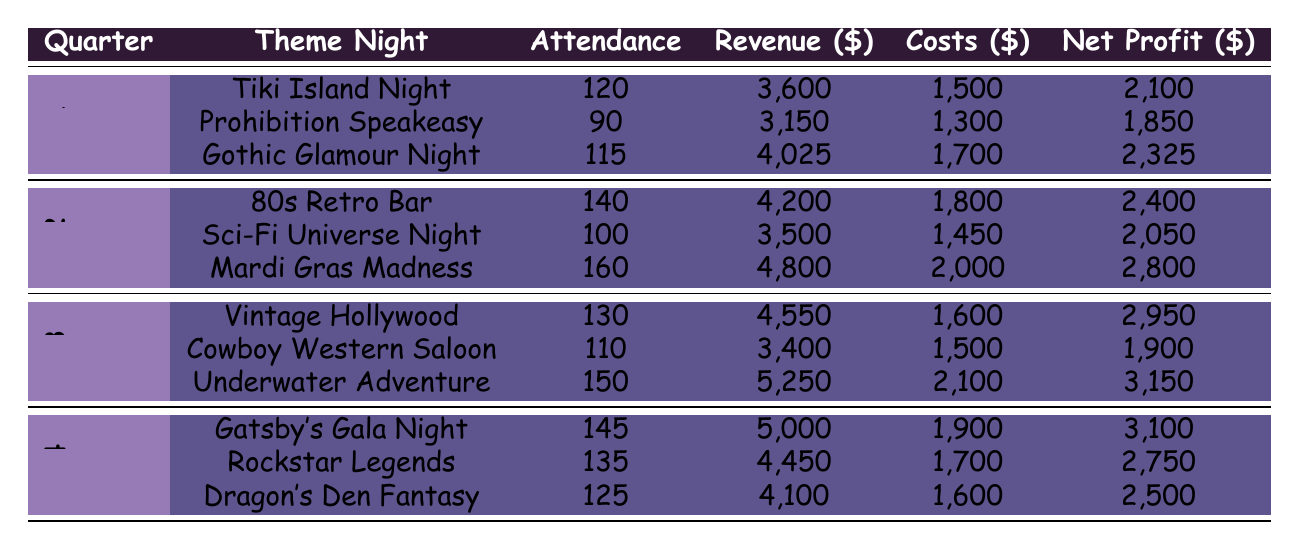What was the theme night with the highest net profit in Q1? In Q1, the net profits for the theme nights are as follows: Tiki Island Night: 2100, Prohibition Speakeasy: 1850, Gothic Glamour Night: 2325. The highest net profit is from Gothic Glamour Night.
Answer: Gothic Glamour Night What was the total attendance across all theme nights in Q2? The attendances for Q2 theme nights are: 80s Retro Bar: 140, Sci-Fi Universe Night: 100, Mardi Gras Madness: 160. Summing these values gives us 140 + 100 + 160 = 400.
Answer: 400 Did the Underwater Adventure theme night in Q3 have higher costs than the Gothic Glamour Night in Q1? The costs for Underwater Adventure in Q3 are 2100 and for Gothic Glamour Night in Q1 are 1700. Since 2100 is greater than 1700, the statement is true.
Answer: Yes Which quarter had the highest overall net profit from all theme nights combined? Calculating net profits for each quarter: Q1 (2100 + 1850 + 2325 = 6275), Q2 (2400 + 2050 + 2800 = 7250), Q3 (2950 + 1900 + 3150 = 8000), Q4 (3100 + 2750 + 2500 = 8350). The highest overall net profit is in Q4 with 8350.
Answer: Q4 What is the average revenue of the 3 theme nights in Q3? The revenues for Q3 theme nights are: Vintage Hollywood: 4550, Cowboy Western Saloon: 3400, Underwater Adventure: 5250. Summing these revenues gives 4550 + 3400 + 5250 = 13200. Dividing by 3 gives the average revenue of 13200/3 = 4400.
Answer: 4400 What was the attendance for the Gatsby's Gala Night in Q4? The attendance for Gatsby's Gala Night in Q4 is directly provided in the table as 145.
Answer: 145 Was the net profit from the Mardi Gras Madness in Q2 greater than the net profit from the Cowboy Western Saloon in Q3? The net profit of Mardi Gras Madness in Q2 is 2800 and for Cowboy Western Saloon in Q3 it is 1900. Since 2800 is greater than 1900, the statement is true.
Answer: Yes How much higher was the revenue from Underwater Adventure in Q3 compared to the revenue from Prohibition Speakeasy in Q1? The revenue for Underwater Adventure in Q3 is 5250, and for Prohibition Speakeasy in Q1 it is 3150. The difference in revenue is 5250 - 3150 = 2100, indicating that Underwater Adventure had 2100 higher revenue.
Answer: 2100 